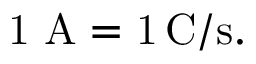<formula> <loc_0><loc_0><loc_500><loc_500>{ 1 \ A = 1 \, { \mathrm { C / s } } . }</formula> 